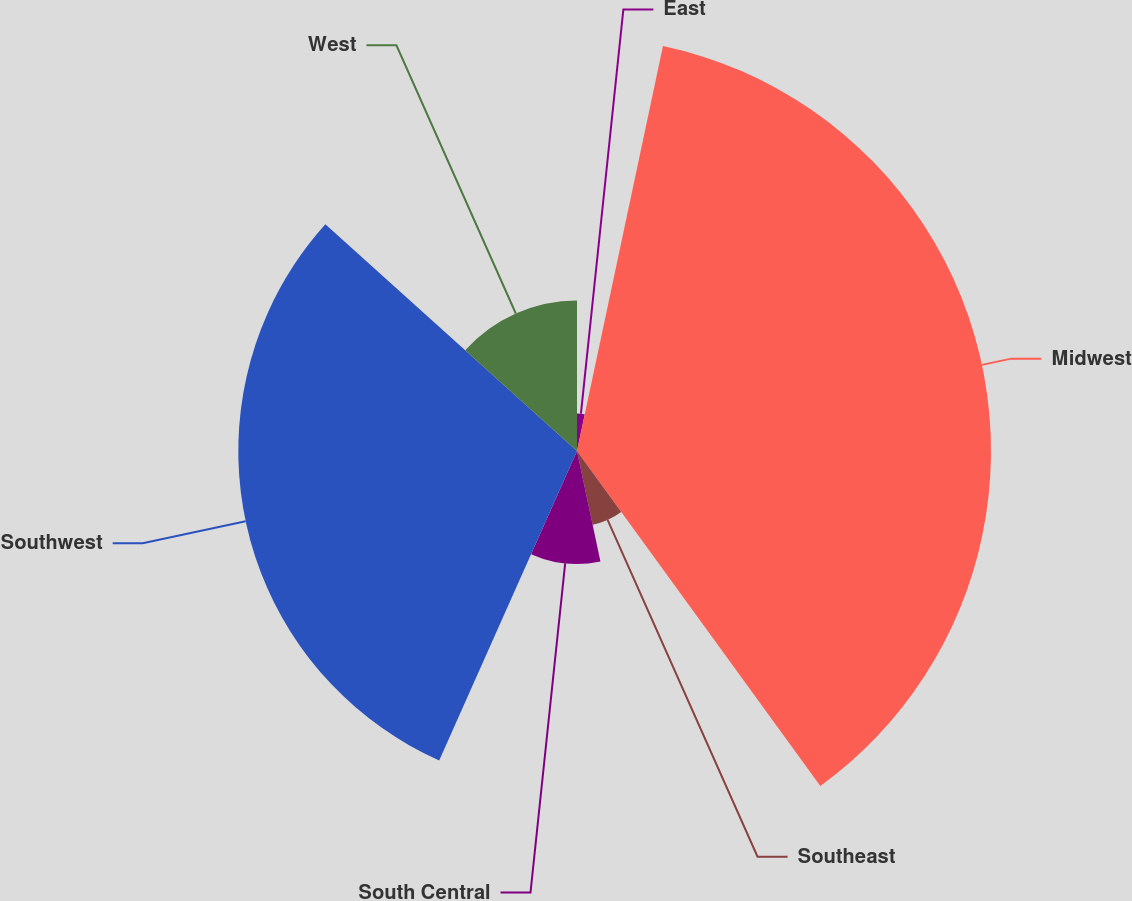Convert chart. <chart><loc_0><loc_0><loc_500><loc_500><pie_chart><fcel>East<fcel>Midwest<fcel>Southeast<fcel>South Central<fcel>Southwest<fcel>West<nl><fcel>3.33%<fcel>36.67%<fcel>6.67%<fcel>10.0%<fcel>30.0%<fcel>13.33%<nl></chart> 